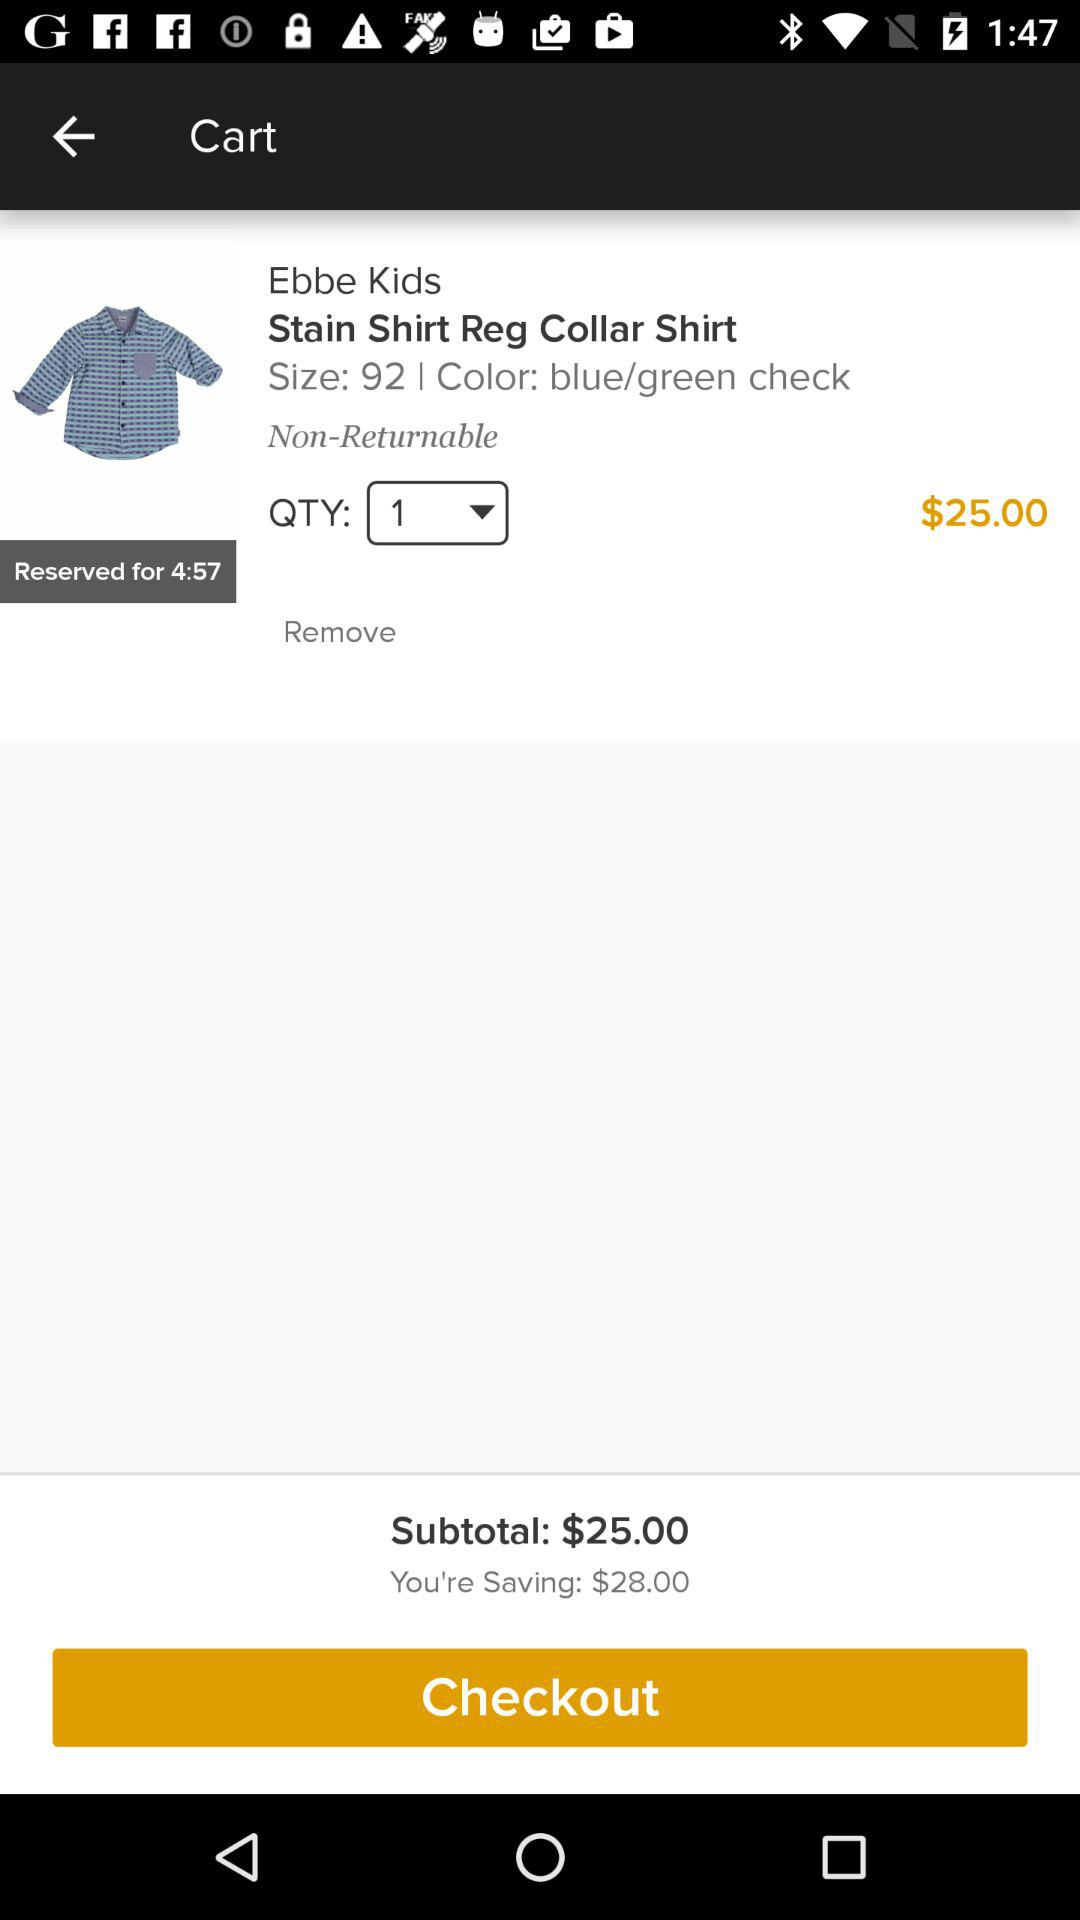What's the size? The size is 92. 